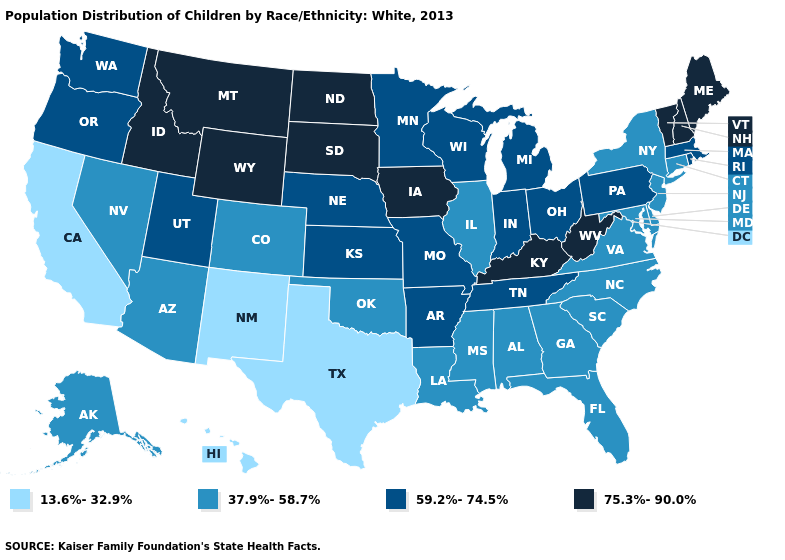Does West Virginia have the highest value in the USA?
Quick response, please. Yes. Does the first symbol in the legend represent the smallest category?
Give a very brief answer. Yes. What is the value of Illinois?
Give a very brief answer. 37.9%-58.7%. What is the highest value in the West ?
Write a very short answer. 75.3%-90.0%. What is the highest value in the USA?
Keep it brief. 75.3%-90.0%. What is the highest value in the USA?
Give a very brief answer. 75.3%-90.0%. Among the states that border Kentucky , which have the highest value?
Give a very brief answer. West Virginia. What is the value of Maryland?
Keep it brief. 37.9%-58.7%. Name the states that have a value in the range 75.3%-90.0%?
Quick response, please. Idaho, Iowa, Kentucky, Maine, Montana, New Hampshire, North Dakota, South Dakota, Vermont, West Virginia, Wyoming. What is the value of Louisiana?
Quick response, please. 37.9%-58.7%. What is the value of Utah?
Write a very short answer. 59.2%-74.5%. What is the value of North Dakota?
Concise answer only. 75.3%-90.0%. Does the first symbol in the legend represent the smallest category?
Give a very brief answer. Yes. Does the first symbol in the legend represent the smallest category?
Concise answer only. Yes. 